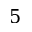Convert formula to latex. <formula><loc_0><loc_0><loc_500><loc_500>5</formula> 